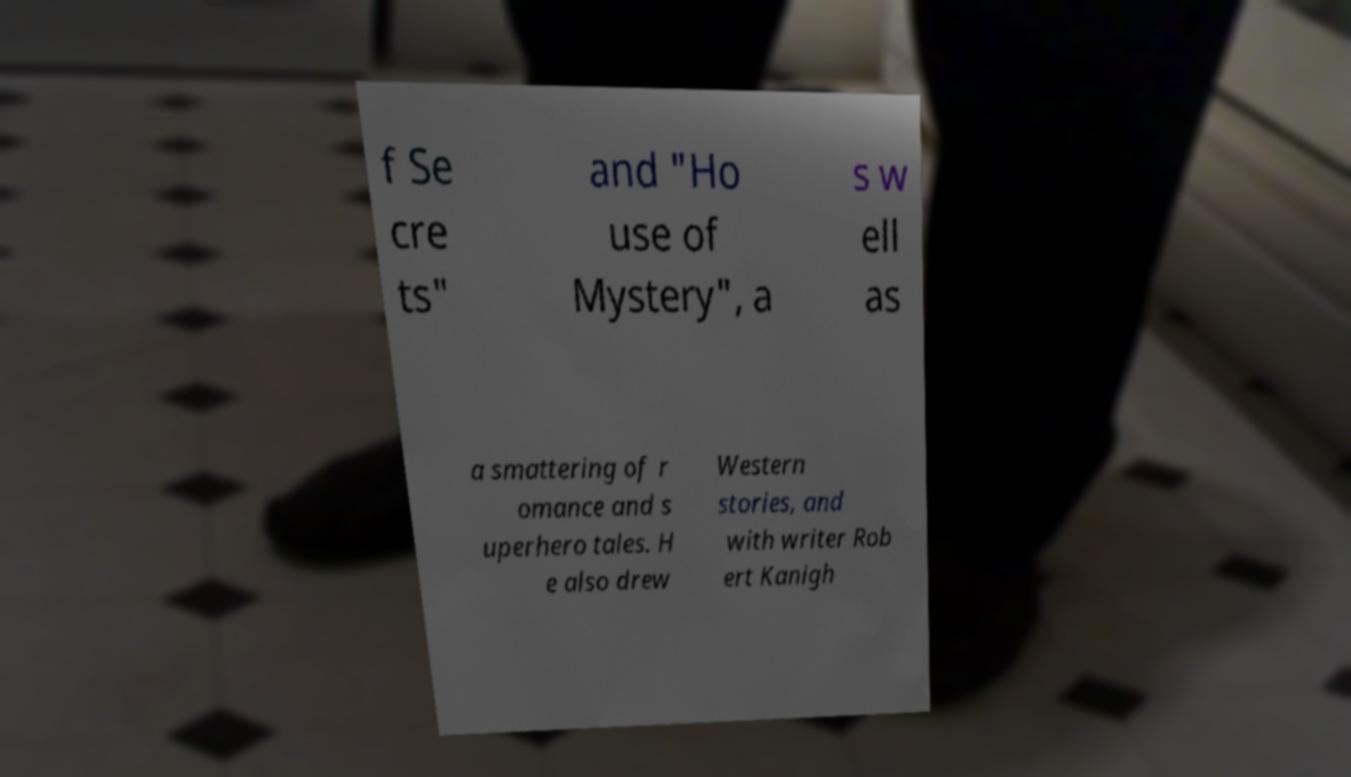Could you extract and type out the text from this image? f Se cre ts" and "Ho use of Mystery", a s w ell as a smattering of r omance and s uperhero tales. H e also drew Western stories, and with writer Rob ert Kanigh 